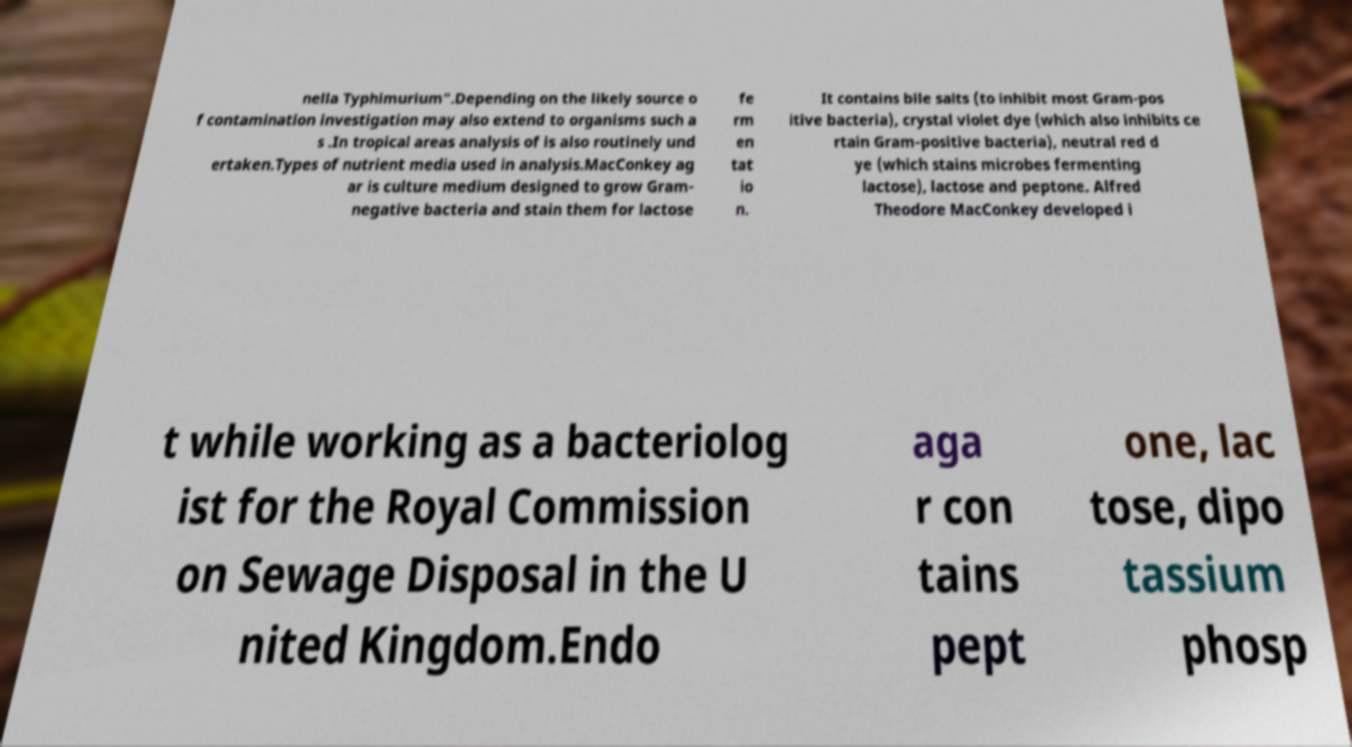What messages or text are displayed in this image? I need them in a readable, typed format. nella Typhimurium".Depending on the likely source o f contamination investigation may also extend to organisms such a s .In tropical areas analysis of is also routinely und ertaken.Types of nutrient media used in analysis.MacConkey ag ar is culture medium designed to grow Gram- negative bacteria and stain them for lactose fe rm en tat io n. It contains bile salts (to inhibit most Gram-pos itive bacteria), crystal violet dye (which also inhibits ce rtain Gram-positive bacteria), neutral red d ye (which stains microbes fermenting lactose), lactose and peptone. Alfred Theodore MacConkey developed i t while working as a bacteriolog ist for the Royal Commission on Sewage Disposal in the U nited Kingdom.Endo aga r con tains pept one, lac tose, dipo tassium phosp 